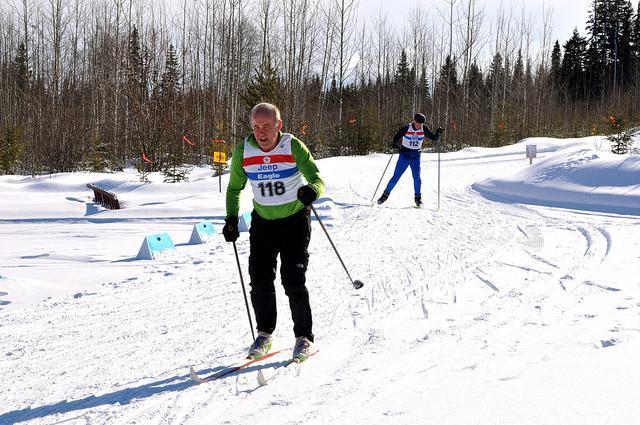How many knives are depicted?
Give a very brief answer. 0. 